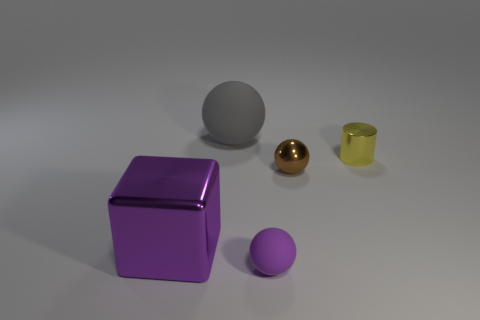Add 1 big purple metal things. How many objects exist? 6 Subtract all balls. How many objects are left? 2 Add 3 yellow things. How many yellow things are left? 4 Add 3 big brown cubes. How many big brown cubes exist? 3 Subtract 0 red cubes. How many objects are left? 5 Subtract all large purple things. Subtract all tiny yellow cylinders. How many objects are left? 3 